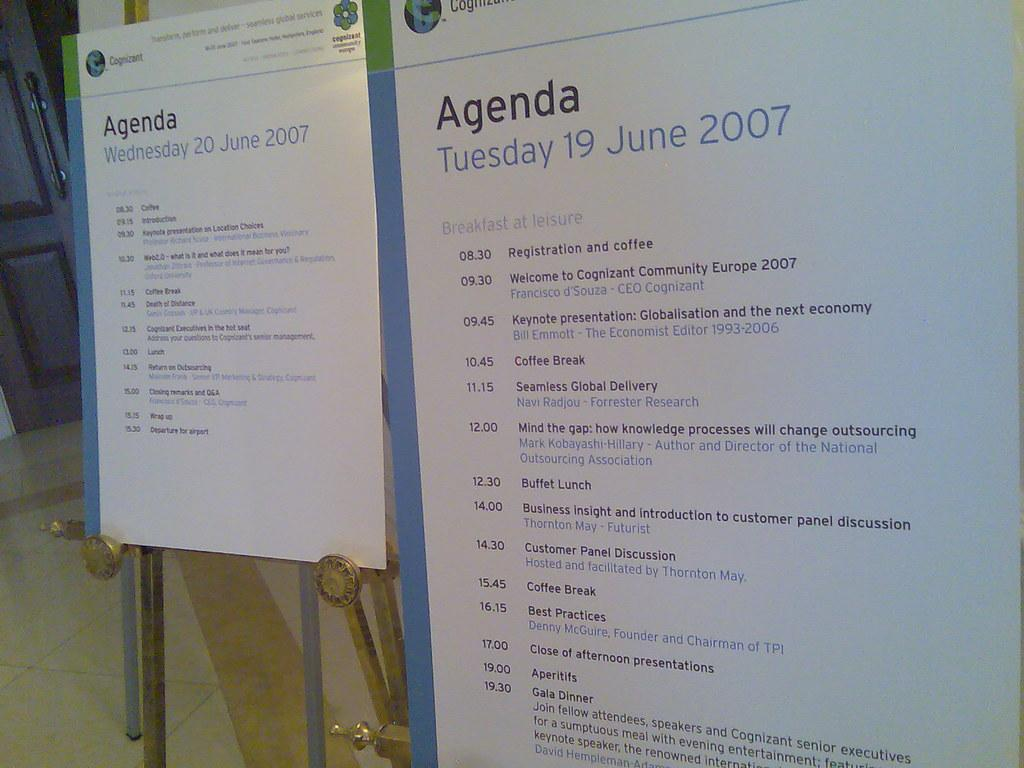What type of object can be seen in the image that is used for displaying information? There are notice boards in the image that are used for displaying information. What can be found on the notice boards? The notice boards contain text. Where is the door located in the image? The door is in the top left of the image. Can you see any worms crawling on the notice boards in the image? There are no worms present in the image. What type of sock is hanging on the door in the image? There is no sock present in the image. 